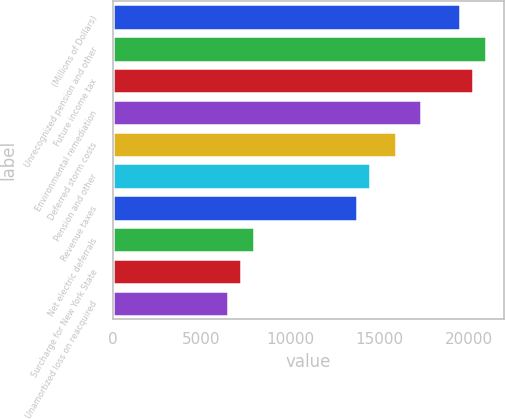Convert chart to OTSL. <chart><loc_0><loc_0><loc_500><loc_500><bar_chart><fcel>(Millions of Dollars)<fcel>Unrecognized pension and other<fcel>Future income tax<fcel>Environmental remediation<fcel>Deferred storm costs<fcel>Pension and other<fcel>Revenue taxes<fcel>Net electric deferrals<fcel>Surcharge for New York State<fcel>Unamortized loss on reacquired<nl><fcel>19507.4<fcel>20951.8<fcel>20229.6<fcel>17340.8<fcel>15896.4<fcel>14452<fcel>13729.8<fcel>7952.2<fcel>7230<fcel>6507.8<nl></chart> 